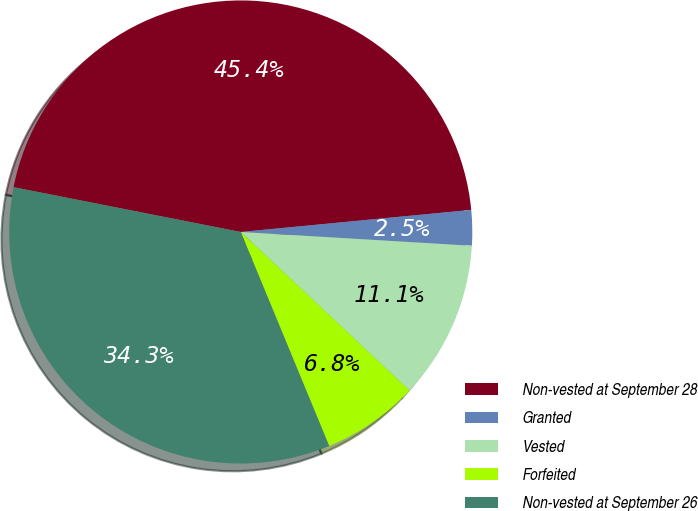Convert chart to OTSL. <chart><loc_0><loc_0><loc_500><loc_500><pie_chart><fcel>Non-vested at September 28<fcel>Granted<fcel>Vested<fcel>Forfeited<fcel>Non-vested at September 26<nl><fcel>45.37%<fcel>2.47%<fcel>11.05%<fcel>6.76%<fcel>34.33%<nl></chart> 